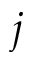<formula> <loc_0><loc_0><loc_500><loc_500>j</formula> 